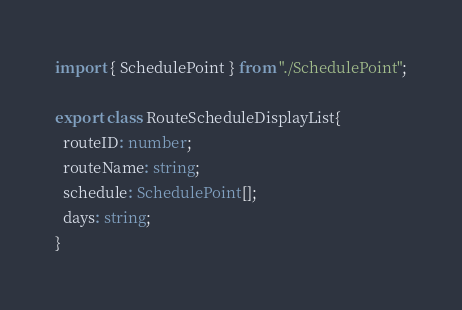<code> <loc_0><loc_0><loc_500><loc_500><_TypeScript_>import { SchedulePoint } from "./SchedulePoint";

export class RouteScheduleDisplayList{
  routeID: number;
  routeName: string;
  schedule: SchedulePoint[];
  days: string;
}</code> 